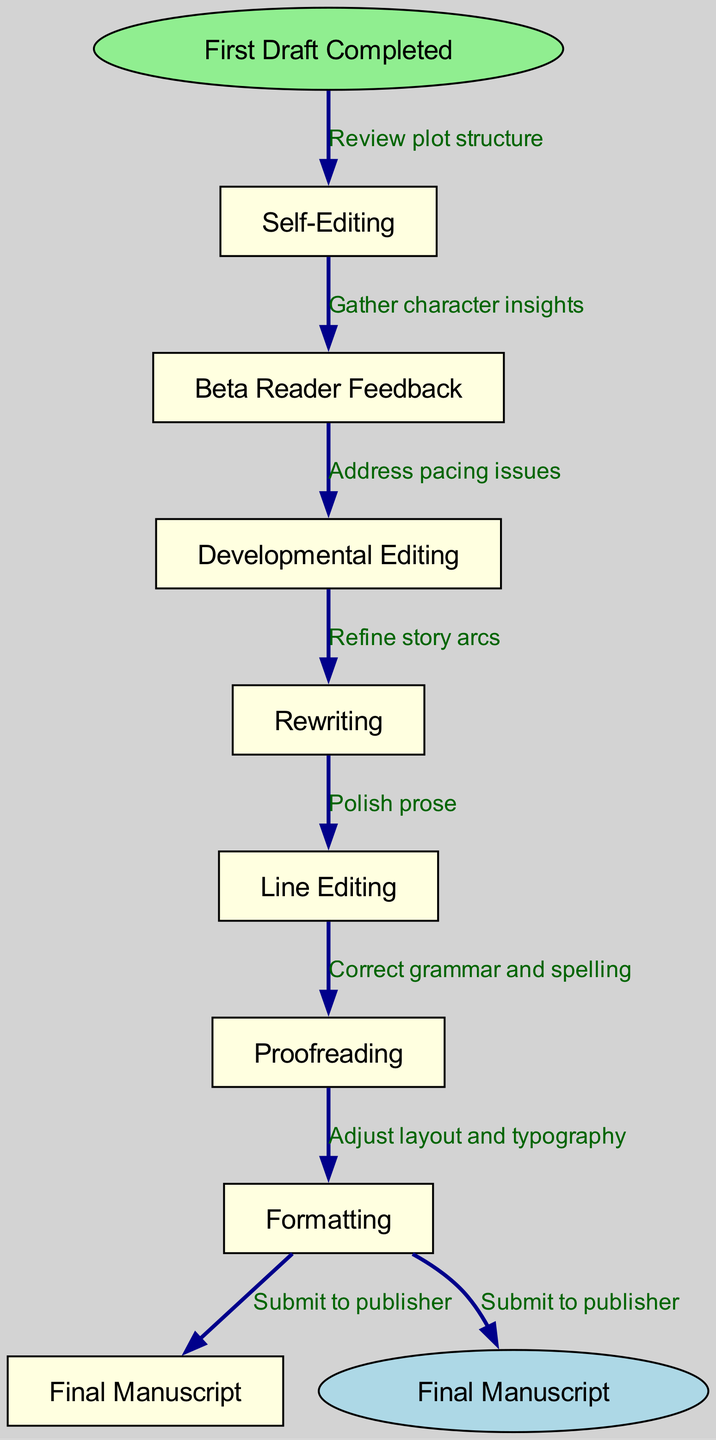What is the starting point of the editing process? The diagram indicates that the starting point is "First Draft Completed," which is shown as the first node in the flow.
Answer: First Draft Completed How many nodes are present in the flow chart? To find the number of nodes, we count the individual nodes listed in the data, which total to eight: the starting point, six editing stages, and the final manuscript.
Answer: Eight Which node comes after "Self-Editing"? The flow chart displays a sequence of nodes, and the node that follows "Self-Editing" is "Beta Reader Feedback," as indicated by the directed edges connecting the nodes.
Answer: Beta Reader Feedback What is the last step before final submission? The diagram shows that the last step before reaching the "Final Manuscript" is "Proofreading," followed by the final submission to the publisher. This step is crucial as it ensures the manuscript is error-free.
Answer: Proofreading What is the relationship between "Rewriting" and "Line Editing"? The flow chart illustrates that "Rewriting" precedes "Line Editing," indicating that after rewriting the draft, the next step in the process is to focus on line editing for finer details.
Answer: Rewriting precedes Line Editing How many edges are there in the diagram? By counting the directed connections or edges between the nodes, we find there are seven edges connecting the eight nodes, illustrating the flow of the editing process.
Answer: Seven What action should be taken after gathering character insights? According to the flow diagram, the action following the gathering of character insights during "Beta Reader Feedback" is "Developmental Editing," emphasizing the importance of refining narrative elements.
Answer: Developmental Editing How does the flow of the editing process progress from drafting to final manuscript? The flow progresses from "First Draft Completed" to "Self-Editing," then to "Beta Reader Feedback," followed by "Developmental Editing," onto "Rewriting," "Line Editing," "Proofreading," and finally to "Final Manuscript," outlining a structured path of refinement.
Answer: Through several editing stages to Final Manuscript 